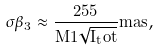Convert formula to latex. <formula><loc_0><loc_0><loc_500><loc_500>\sigma \beta _ { 3 } \approx \frac { 2 5 5 } { M 1 \sqrt { I _ { t } o t } } m a s ,</formula> 